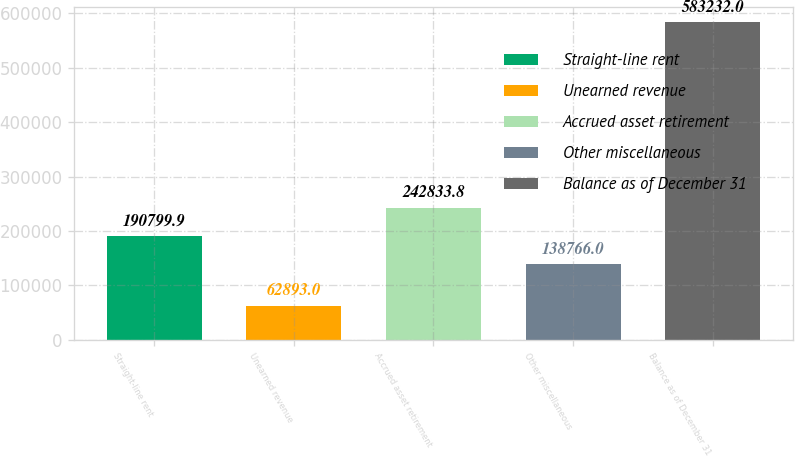<chart> <loc_0><loc_0><loc_500><loc_500><bar_chart><fcel>Straight-line rent<fcel>Unearned revenue<fcel>Accrued asset retirement<fcel>Other miscellaneous<fcel>Balance as of December 31<nl><fcel>190800<fcel>62893<fcel>242834<fcel>138766<fcel>583232<nl></chart> 